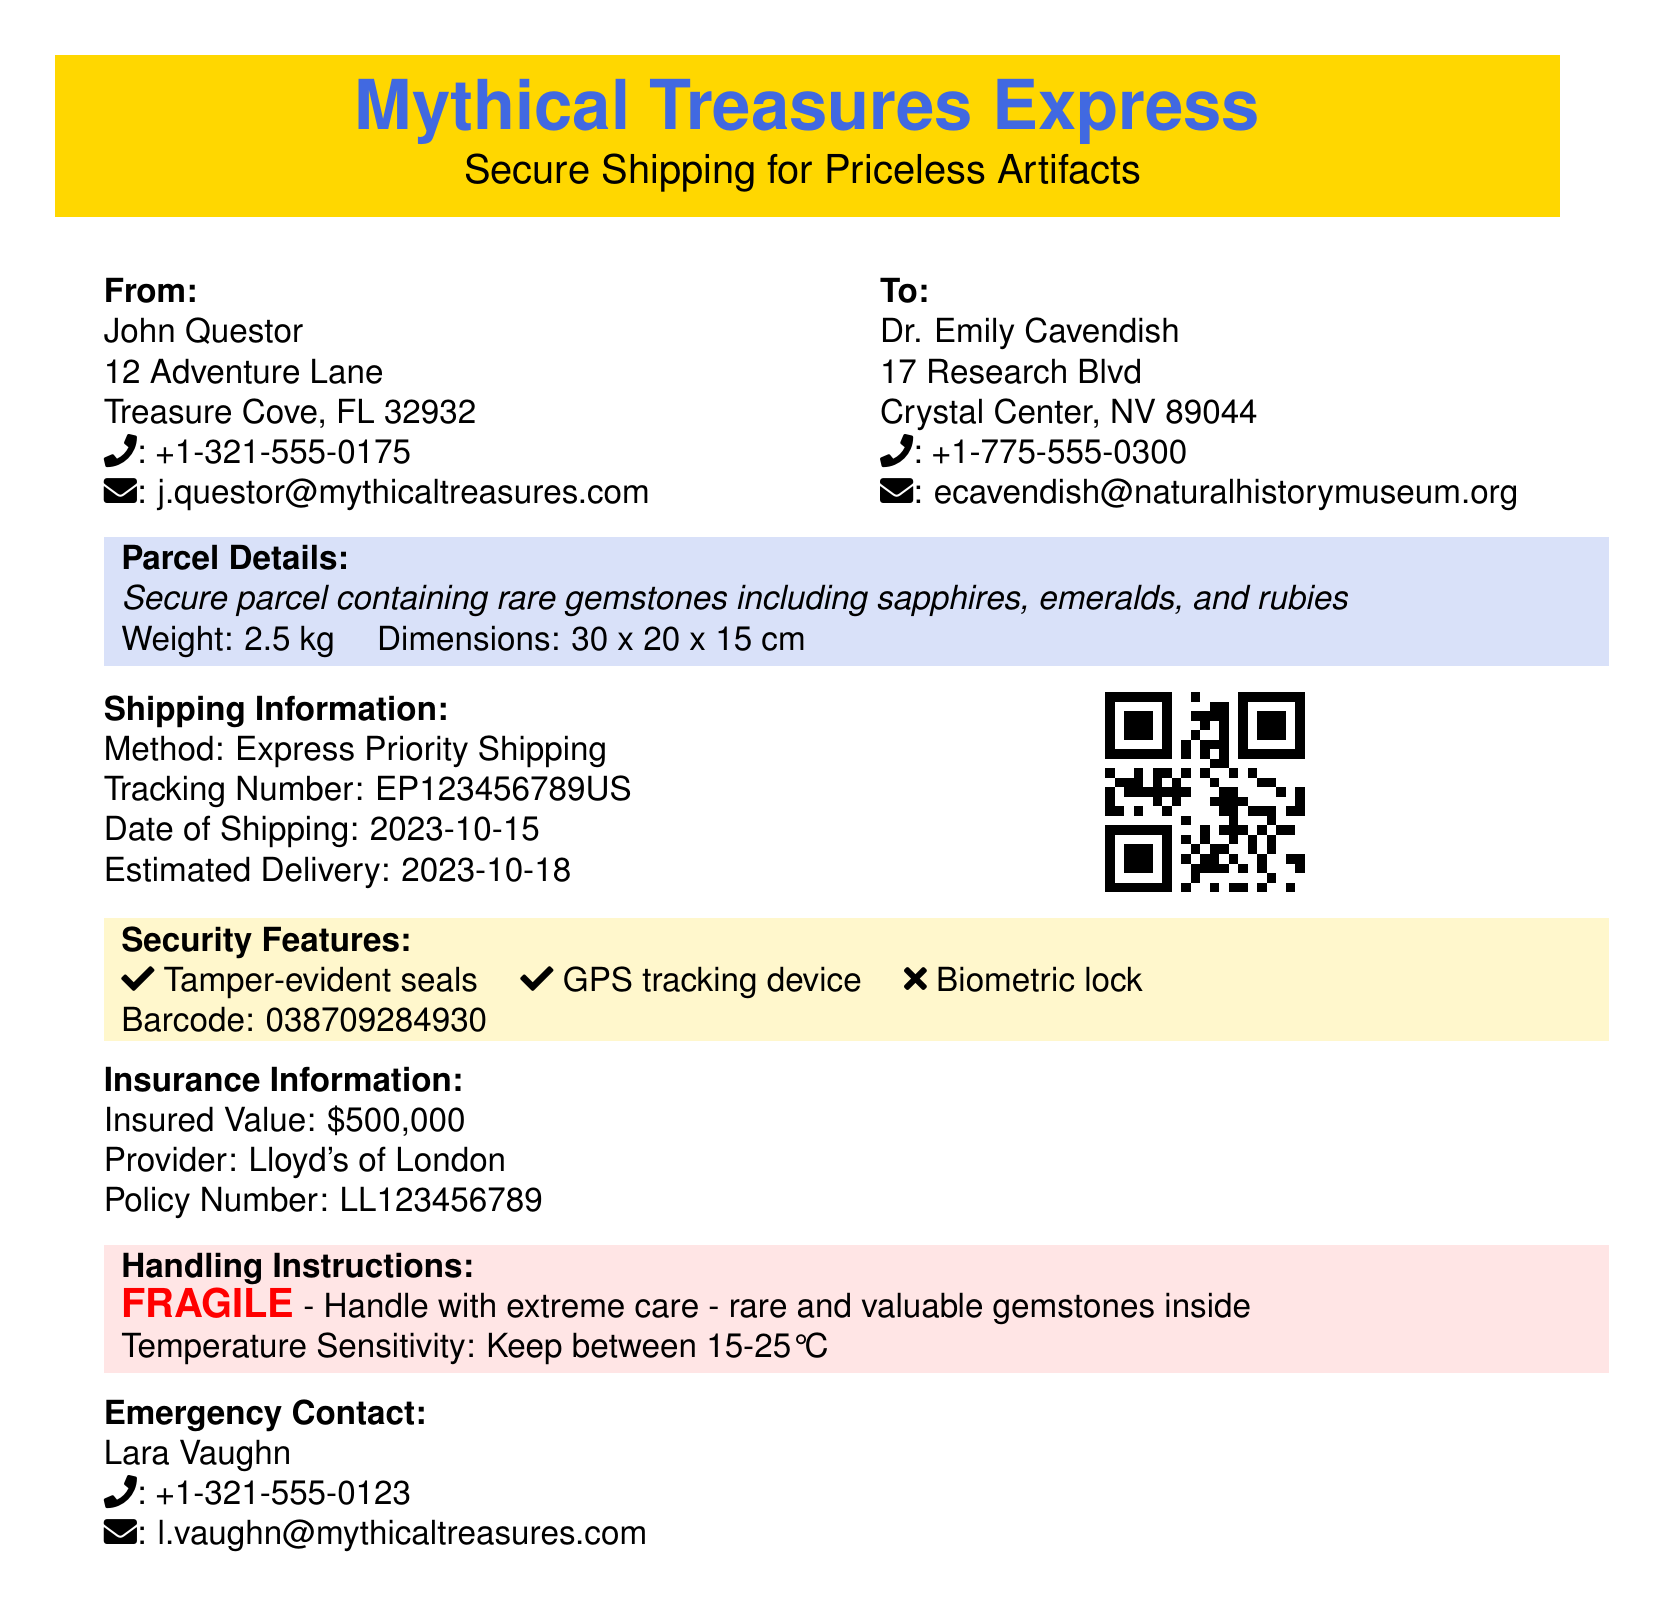What is the shipping method? The shipping method is mentioned in the 'Shipping Information' section.
Answer: Express Priority Shipping What is the weight of the parcel? The weight can be found in the 'Parcel Details' section of the document.
Answer: 2.5 kg Who is the sender? The sender's name is listed under the 'From' section near the top of the document.
Answer: John Questor What is the insured value of the parcel? The insured value is provided in the 'Insurance Information' section of the document.
Answer: $500,000 What is the tracking number? The tracking number is specified in the 'Shipping Information' section.
Answer: EP123456789US What security feature is not included? This question requires evaluating the listed security features to identify what is absent.
Answer: Biometric lock What is the emergency contact's email? The emergency contact's email can be found in the 'Emergency Contact' section.
Answer: l.vaughn@mythicaltreasures.com When is the estimated delivery date? The estimated delivery date is stated in the 'Shipping Information' part of the label.
Answer: 2023-10-18 What fragile item is inside the parcel? The nature of the contents is described in the 'Parcel Details' section.
Answer: rare gemstones 